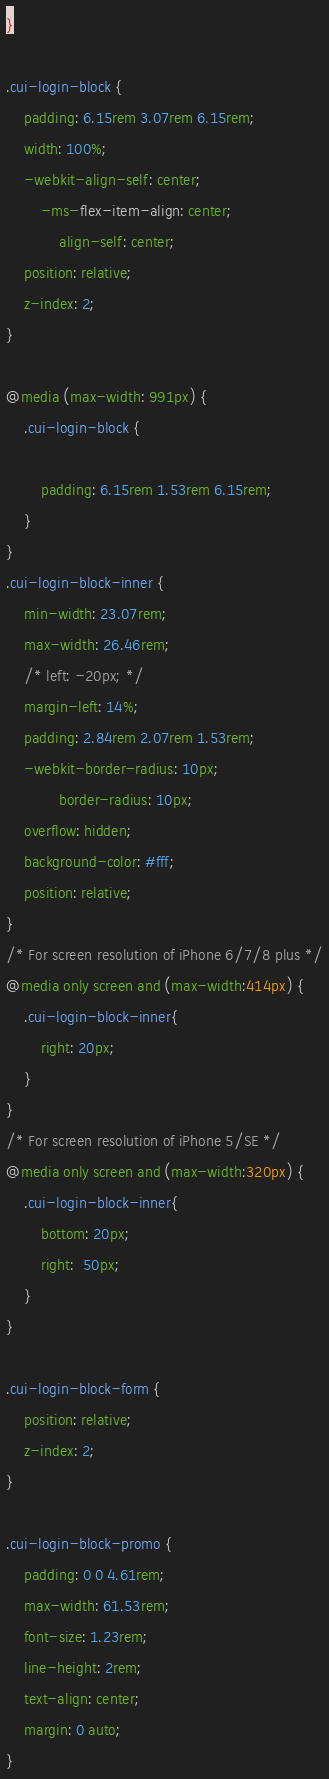<code> <loc_0><loc_0><loc_500><loc_500><_CSS_>}

.cui-login-block {
    padding: 6.15rem 3.07rem 6.15rem;
    width: 100%;
    -webkit-align-self: center;
        -ms-flex-item-align: center;
            align-self: center;
    position: relative;
    z-index: 2;
}

@media (max-width: 991px) {
    .cui-login-block {

        padding: 6.15rem 1.53rem 6.15rem;
    }
}
.cui-login-block-inner {
    min-width: 23.07rem;
    max-width: 26.46rem;
    /* left: -20px; */
    margin-left: 14%;
    padding: 2.84rem 2.07rem 1.53rem;
    -webkit-border-radius: 10px;
            border-radius: 10px;
    overflow: hidden;
    background-color: #fff;
    position: relative;
}
/* For screen resolution of iPhone 6/7/8 plus */
@media only screen and (max-width:414px) {
    .cui-login-block-inner{
        right: 20px;
    }
}
/* For screen resolution of iPhone 5/SE */
@media only screen and (max-width:320px) {
    .cui-login-block-inner{
        bottom: 20px;
        right:  50px;
    }
}

.cui-login-block-form {
    position: relative;
    z-index: 2;
}

.cui-login-block-promo {
    padding: 0 0 4.61rem;
    max-width: 61.53rem;
    font-size: 1.23rem;
    line-height: 2rem;
    text-align: center;
    margin: 0 auto;
}
</code> 